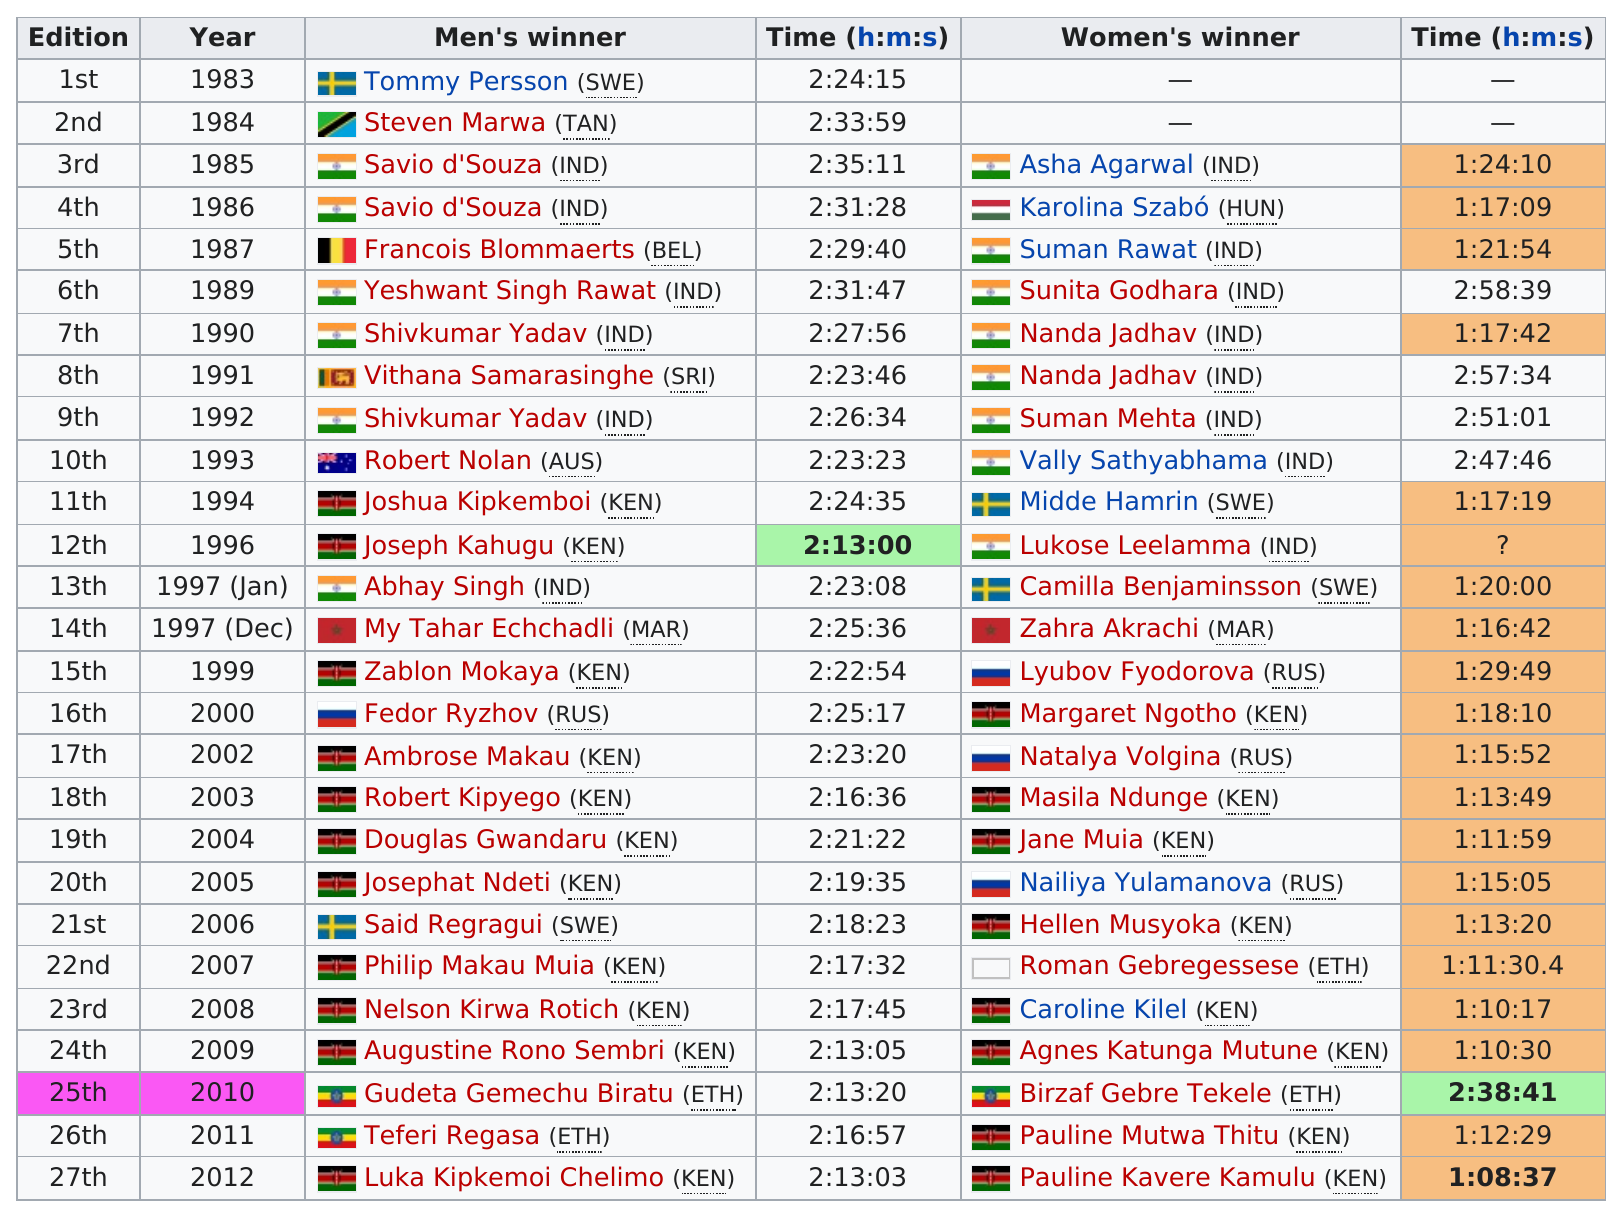Give some essential details in this illustration. Savio d'Souza, the men's winner, had the greatest time. The marathon for Camilla Benjaminsson lasted for 1 hour and 20 minutes, resulting in a total time of 1:20:00. The country of the men's winner and the country of the women's winner were the same in 1985. The last year in which India had a winner was 1997. The marathon was completed in the shortest time since 1990, with a time of 2 hours and 13 minutes. 